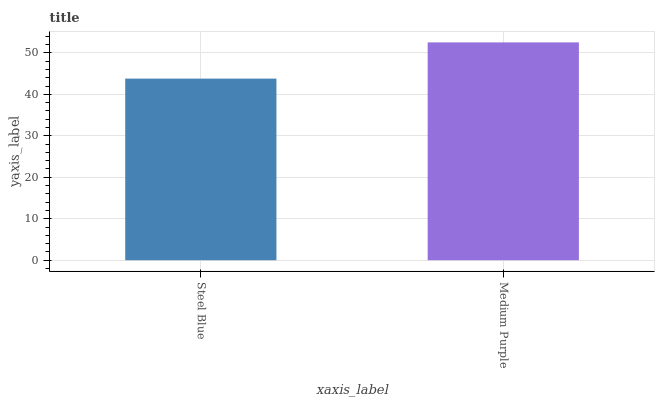Is Steel Blue the minimum?
Answer yes or no. Yes. Is Medium Purple the maximum?
Answer yes or no. Yes. Is Medium Purple the minimum?
Answer yes or no. No. Is Medium Purple greater than Steel Blue?
Answer yes or no. Yes. Is Steel Blue less than Medium Purple?
Answer yes or no. Yes. Is Steel Blue greater than Medium Purple?
Answer yes or no. No. Is Medium Purple less than Steel Blue?
Answer yes or no. No. Is Medium Purple the high median?
Answer yes or no. Yes. Is Steel Blue the low median?
Answer yes or no. Yes. Is Steel Blue the high median?
Answer yes or no. No. Is Medium Purple the low median?
Answer yes or no. No. 